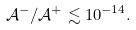Convert formula to latex. <formula><loc_0><loc_0><loc_500><loc_500>\mathcal { A } ^ { - } / \mathcal { A } ^ { + } \lesssim 1 0 ^ { - 1 4 } .</formula> 